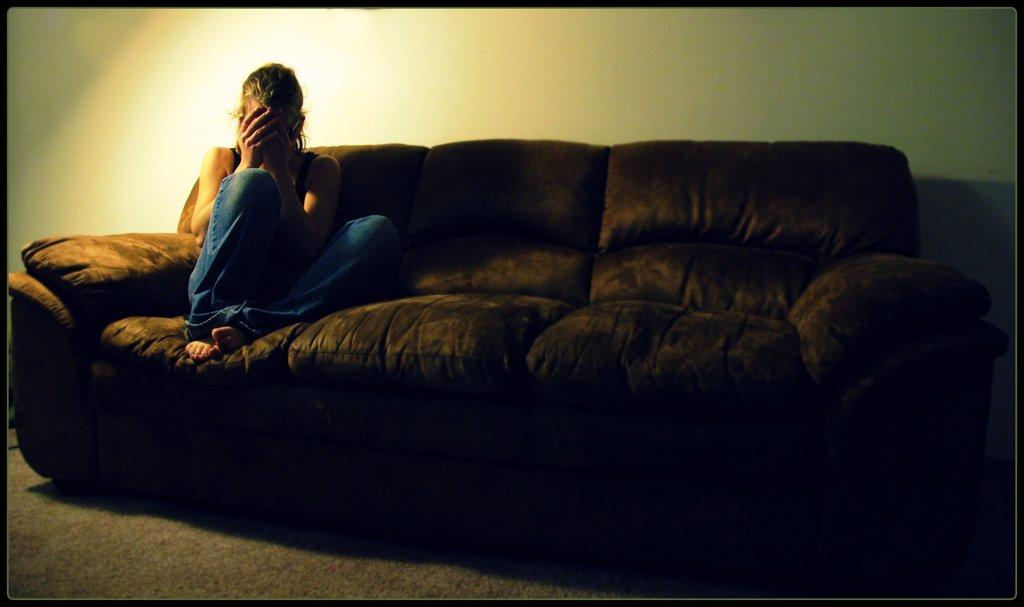Who is the main subject in the image? There is a girl in the image. What is the girl doing in the image? The girl is sitting on a couch. What can be seen in the background of the image? There is a wall in the background of the image. What type of rod is the girl using to participate in the committee meeting in the image? There is no rod or committee meeting present in the image. 